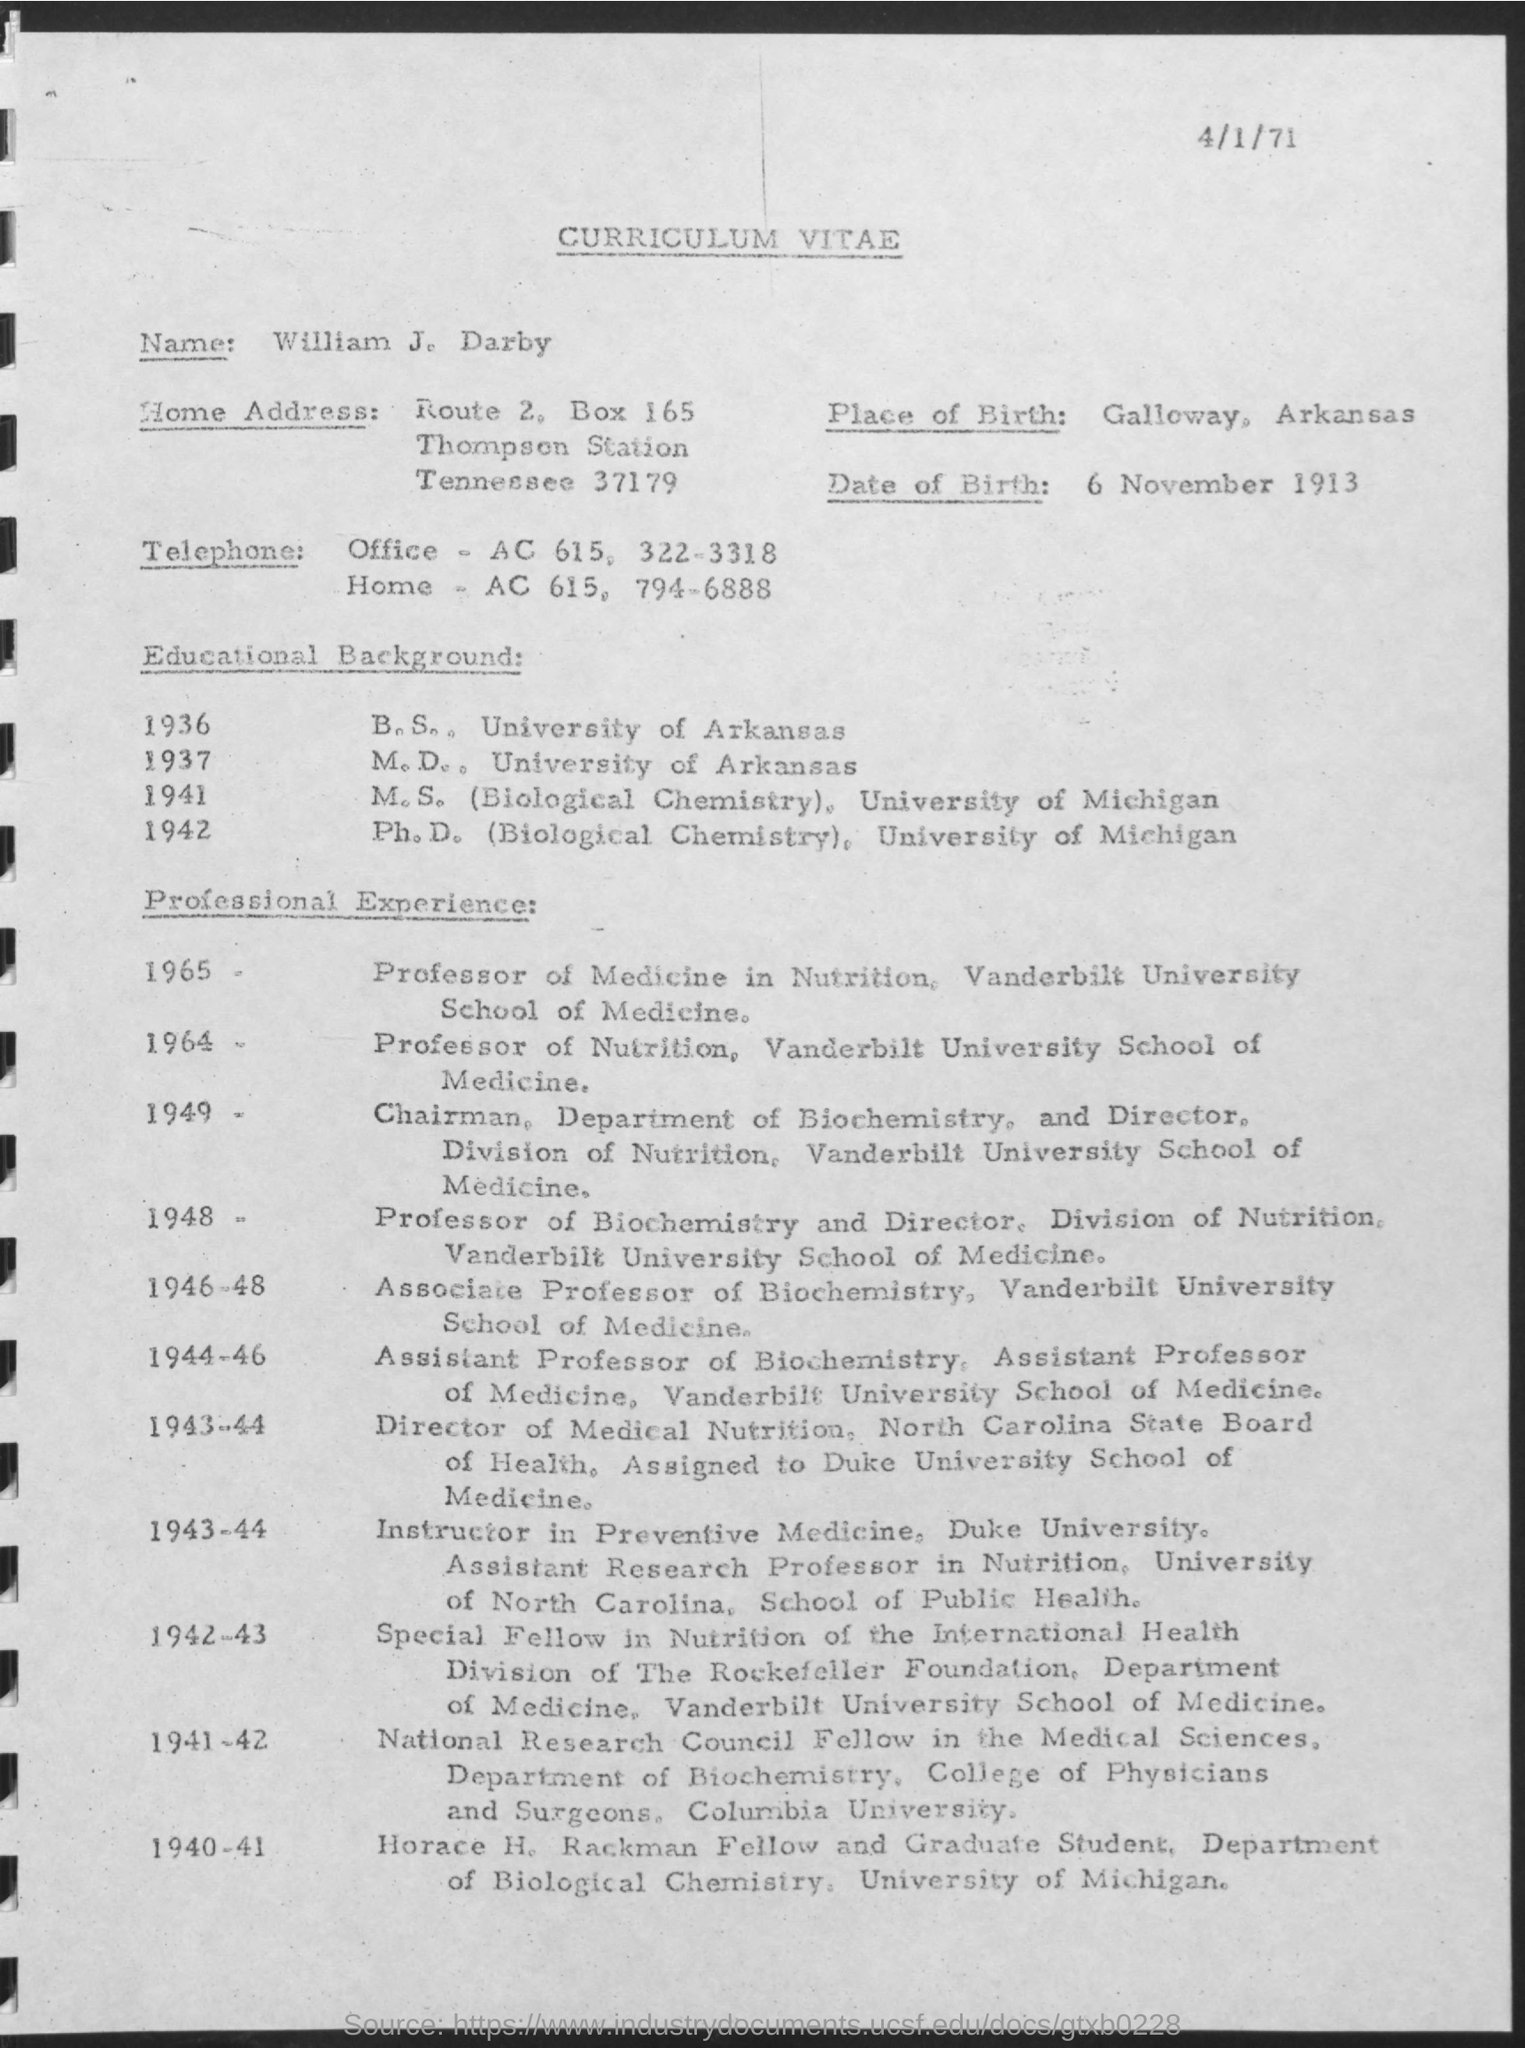What is written in the Letter Head ?
Your response must be concise. CURRICULUM VITAE. What is the Box Number ?
Your answer should be very brief. 165. When he completed B.S ?
Keep it short and to the point. 1936. What is the date mentioned in the top of the document ?
Make the answer very short. 4/1/71. Where is the Place of Birth ?
Your response must be concise. Galloway, Arkansas. What is the Date of Birth of William ?
Provide a succinct answer. 6 November 1913. Where he completed M.D.. ?
Ensure brevity in your answer.  University of Arkansas. 